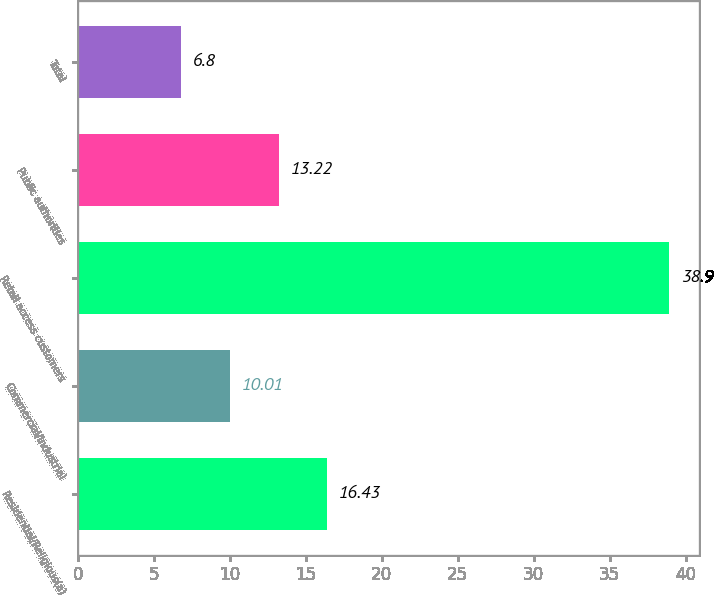Convert chart. <chart><loc_0><loc_0><loc_500><loc_500><bar_chart><fcel>Residential/Religious(a)<fcel>Commercial/Industrial<fcel>Retail access customers<fcel>Public authorities<fcel>Total<nl><fcel>16.43<fcel>10.01<fcel>38.9<fcel>13.22<fcel>6.8<nl></chart> 